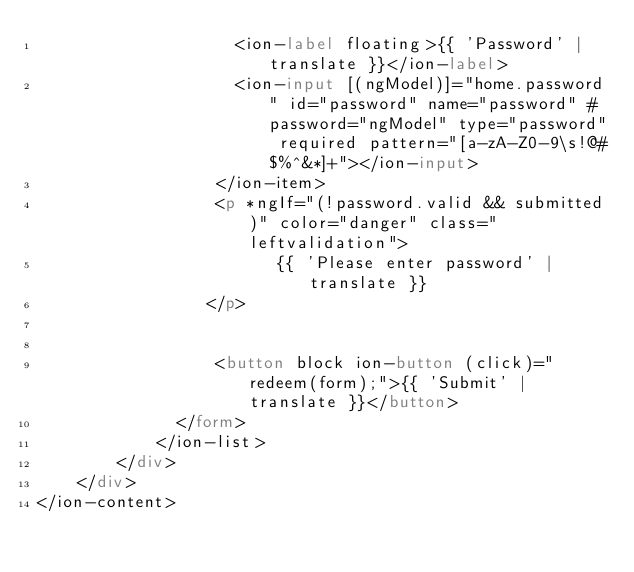Convert code to text. <code><loc_0><loc_0><loc_500><loc_500><_HTML_>                    <ion-label floating>{{ 'Password' | translate }}</ion-label>
                    <ion-input [(ngModel)]="home.password" id="password" name="password" #password="ngModel" type="password" required pattern="[a-zA-Z0-9\s!@#$%^&*]+"></ion-input>
                  </ion-item>
				  <p *ngIf="(!password.valid && submitted)" color="danger" class="leftvalidation">
				        {{ 'Please enter password' | translate }}
			     </p>
				   
				 
                  <button block ion-button (click)="redeem(form);">{{ 'Submit' | translate }}</button>
              </form>
            </ion-list>
		</div>
	</div>
</ion-content>
</code> 